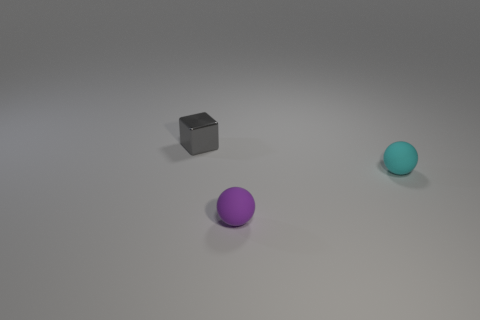Add 3 large blue spheres. How many objects exist? 6 Subtract all small cyan rubber balls. Subtract all big cyan balls. How many objects are left? 2 Add 1 small objects. How many small objects are left? 4 Add 1 metal blocks. How many metal blocks exist? 2 Subtract all cyan balls. How many balls are left? 1 Subtract 0 purple cylinders. How many objects are left? 3 Subtract all blocks. How many objects are left? 2 Subtract 1 spheres. How many spheres are left? 1 Subtract all purple blocks. Subtract all brown spheres. How many blocks are left? 1 Subtract all brown spheres. How many purple cubes are left? 0 